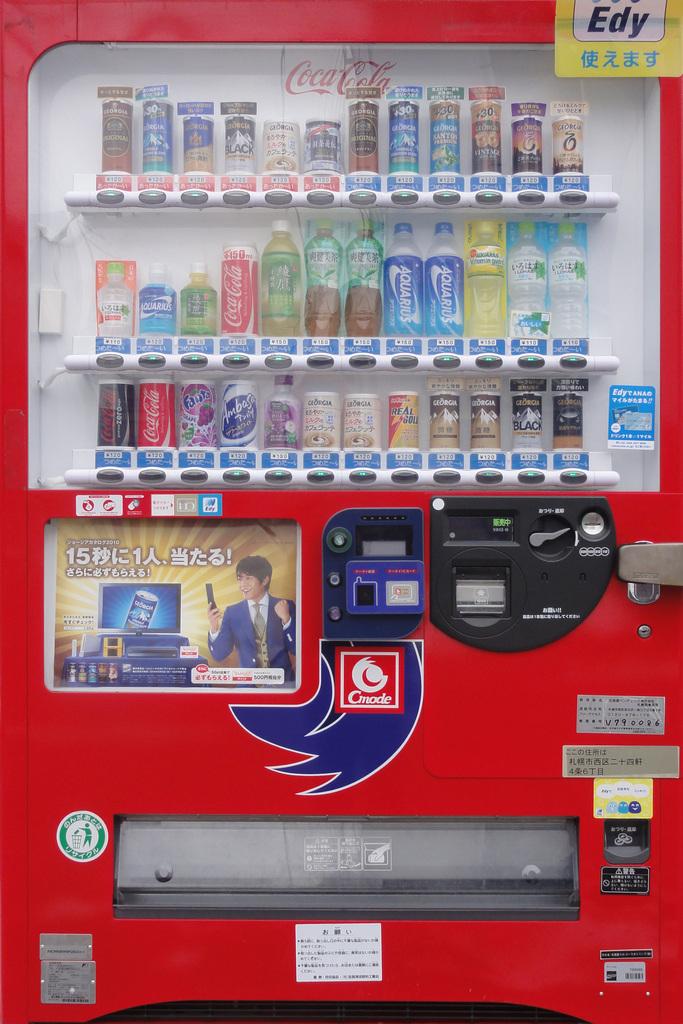What beverage brand is written in red on top of this machine?
Offer a very short reply. Coca cola. 